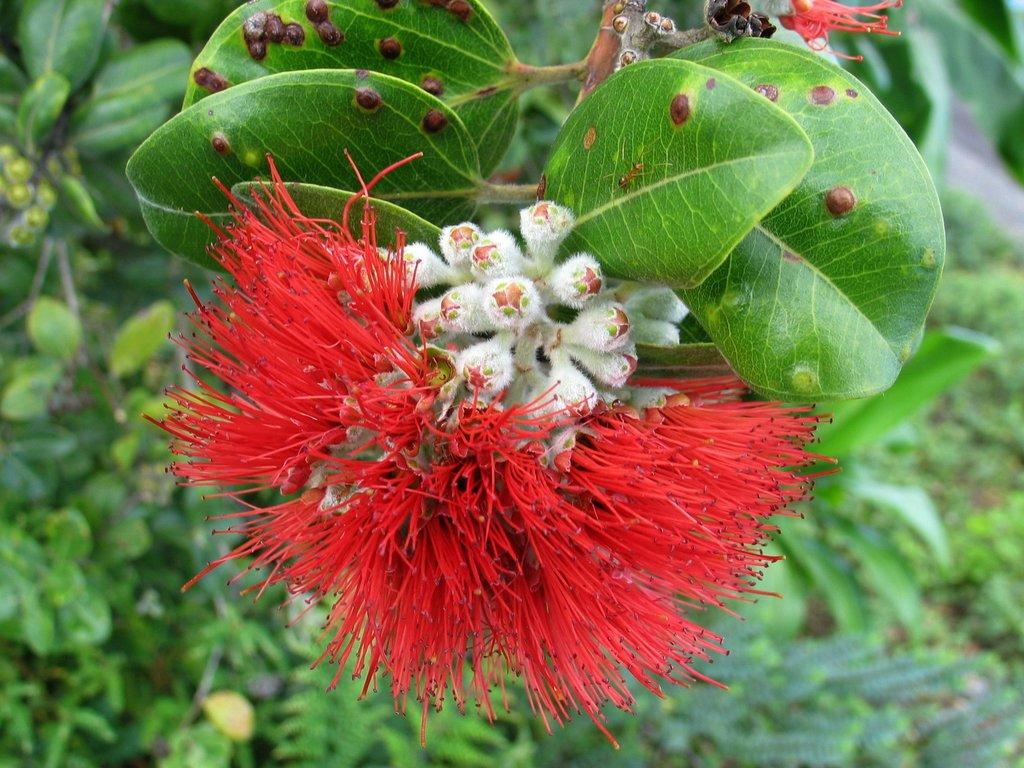What type of flower can be seen in the image? There is a red color flower in the image. Are there any unopened flowers visible in the image? Yes, there are white color flower buds in the image. What is the main subject of the image? There is a plant in the image. What can be seen in the background of the image? There are plants in the background of the image. What type of dolls can be seen interacting with the sky in the image? There are no dolls or interaction with the sky present in the image. 